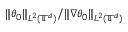<formula> <loc_0><loc_0><loc_500><loc_500>\| \theta _ { 0 } \| _ { L ^ { 2 } ( { \mathbb { T } } ^ { d } ) } / \| \nabla \theta _ { 0 } \| _ { L ^ { 2 } ( { \mathbb { T } } ^ { d } ) }</formula> 